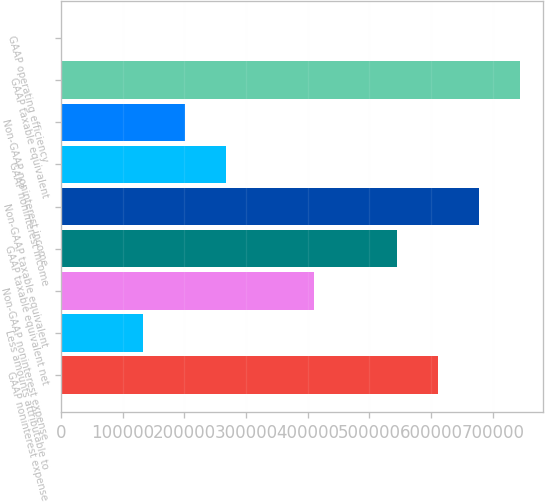<chart> <loc_0><loc_0><loc_500><loc_500><bar_chart><fcel>GAAP noninterest expense<fcel>Less amounts attributable to<fcel>Non-GAAP noninterest expense<fcel>GAAP taxable equivalent net<fcel>Non-GAAP taxable equivalent<fcel>GAAP noninterest income<fcel>Non-GAAP noninterest income<fcel>GAAP taxable equivalent<fcel>GAAP operating efficiency<nl><fcel>610766<fcel>133594<fcel>410470<fcel>544001<fcel>677531<fcel>267124<fcel>200359<fcel>744296<fcel>63.32<nl></chart> 